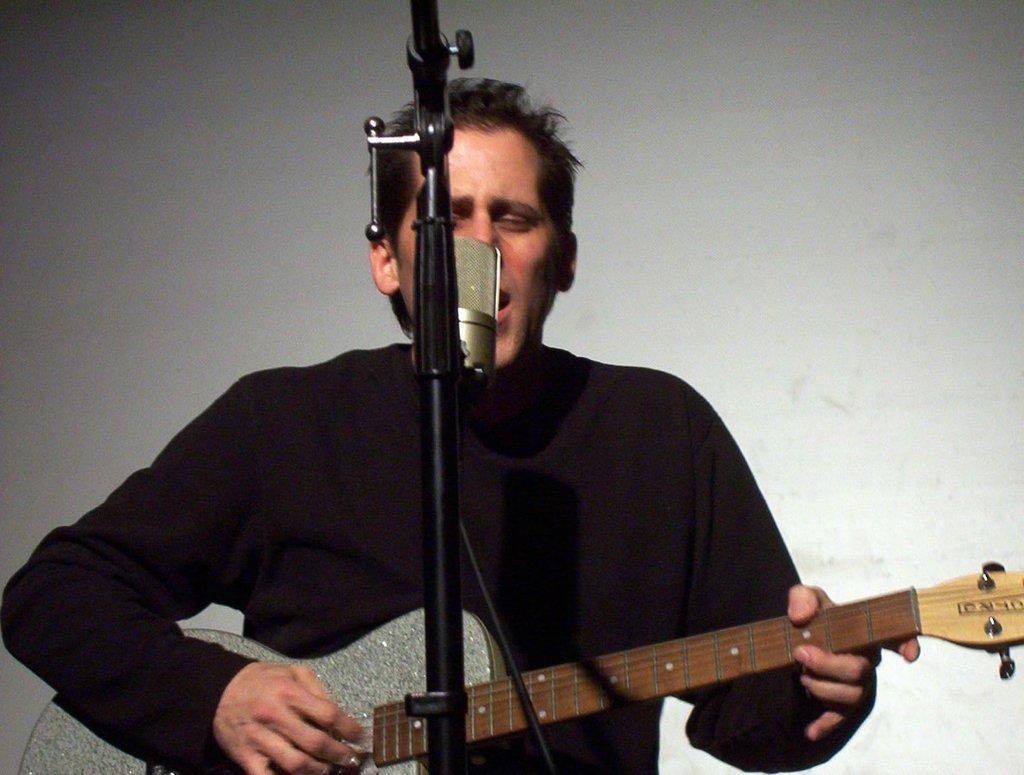How would you summarize this image in a sentence or two? This is a picture of a person who is holding a guitar and playing it in front of a mike who is wearing a black tee shirt and the background is ash in color. 